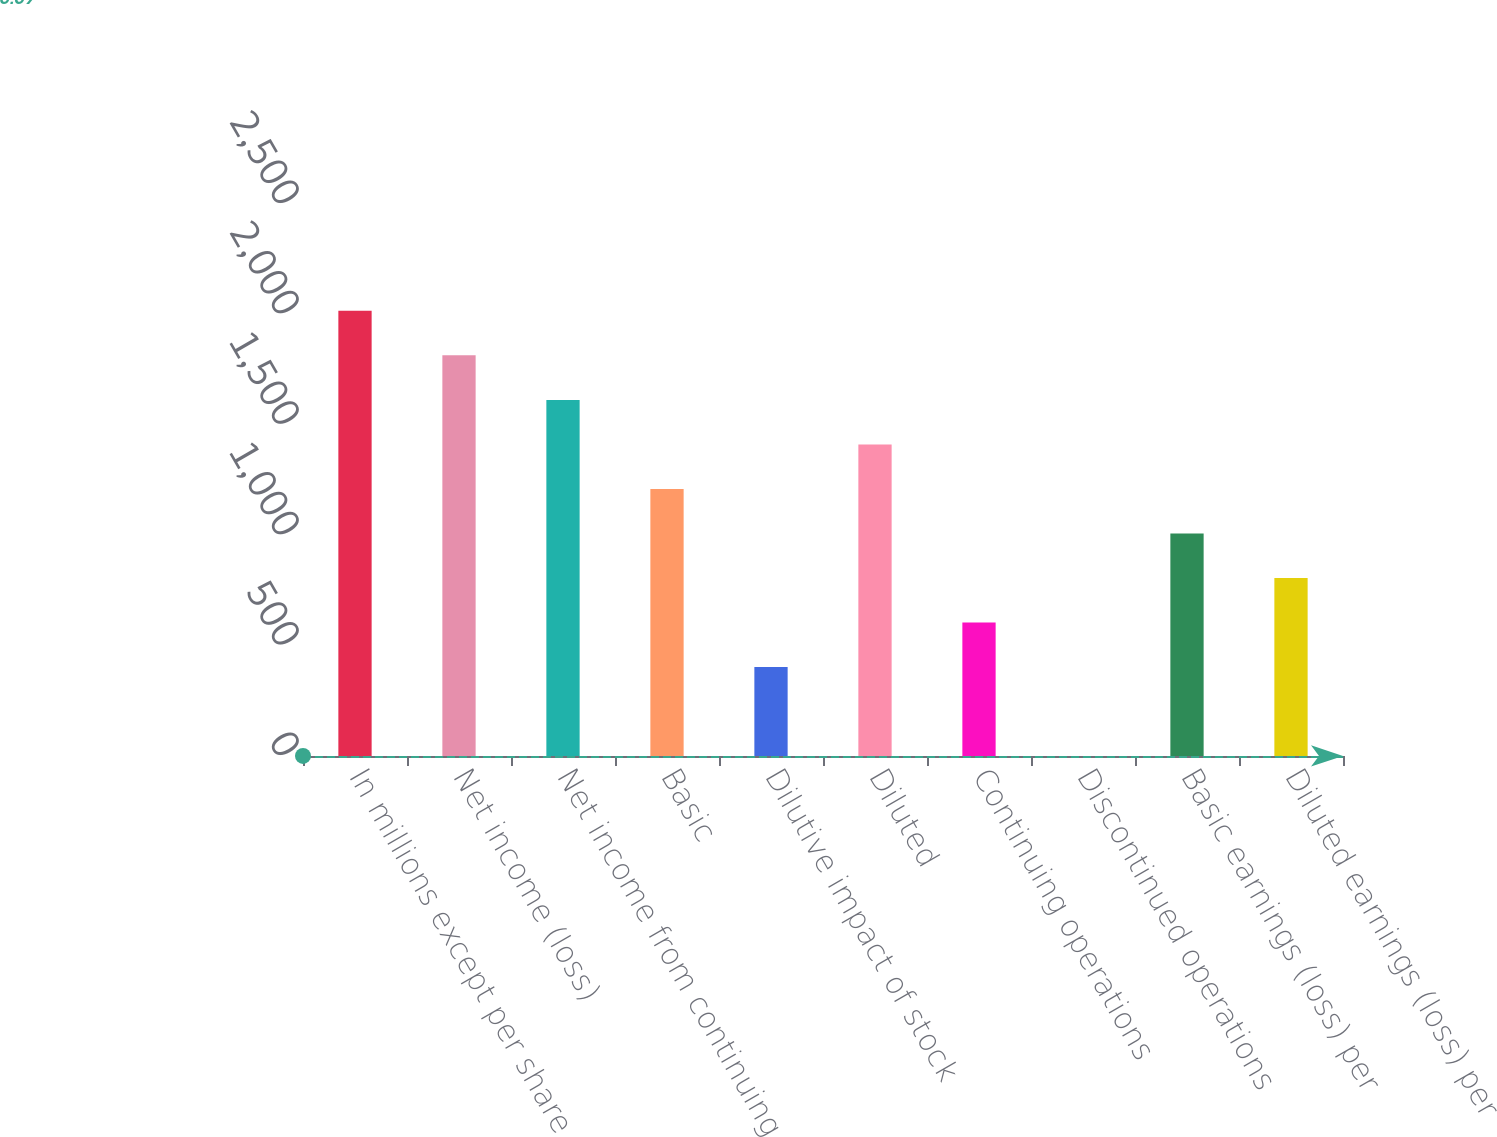Convert chart to OTSL. <chart><loc_0><loc_0><loc_500><loc_500><bar_chart><fcel>In millions except per share<fcel>Net income (loss)<fcel>Net income from continuing<fcel>Basic<fcel>Dilutive impact of stock<fcel>Diluted<fcel>Continuing operations<fcel>Discontinued operations<fcel>Basic earnings (loss) per<fcel>Diluted earnings (loss) per<nl><fcel>2016<fcel>1814.43<fcel>1612.87<fcel>1209.75<fcel>403.51<fcel>1411.31<fcel>605.07<fcel>0.39<fcel>1008.19<fcel>806.63<nl></chart> 